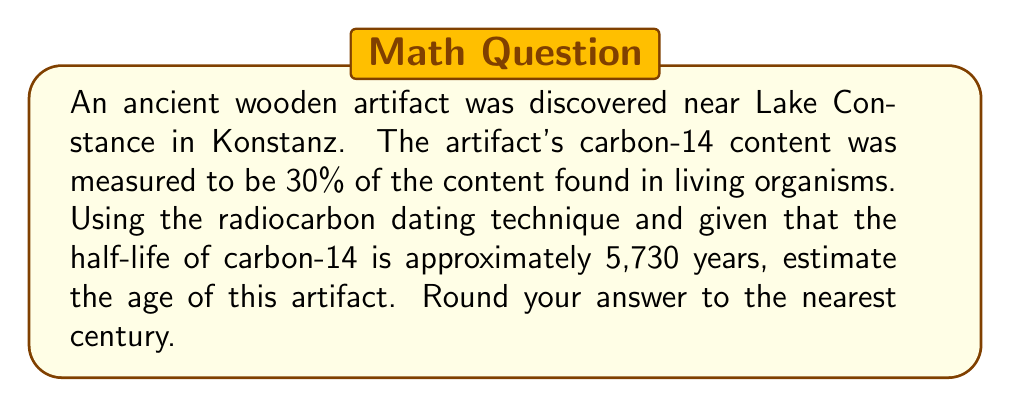Solve this math problem. To solve this problem, we'll use the radioactive decay formula and the given information:

1. Let $N_0$ be the initial amount of carbon-14, and $N$ be the amount remaining after time $t$.
2. The ratio $N/N_0$ is 0.30, or 30% of the original content.
3. The half-life of carbon-14 is 5,730 years.

The radioactive decay formula is:

$$ N = N_0 \cdot 2^{-t/t_{1/2}} $$

Where $t_{1/2}$ is the half-life.

Substituting our known values:

$$ 0.30 = 1 \cdot 2^{-t/5730} $$

To solve for $t$, we take the natural log of both sides:

$$ \ln(0.30) = -t/5730 \cdot \ln(2) $$

Rearranging:

$$ t = -5730 \cdot \ln(0.30) / \ln(2) $$

Calculating:

$$ t \approx 9,968.5 \text{ years} $$

Rounding to the nearest century:

$$ t \approx 10,000 \text{ years} $$
Answer: 10,000 years 